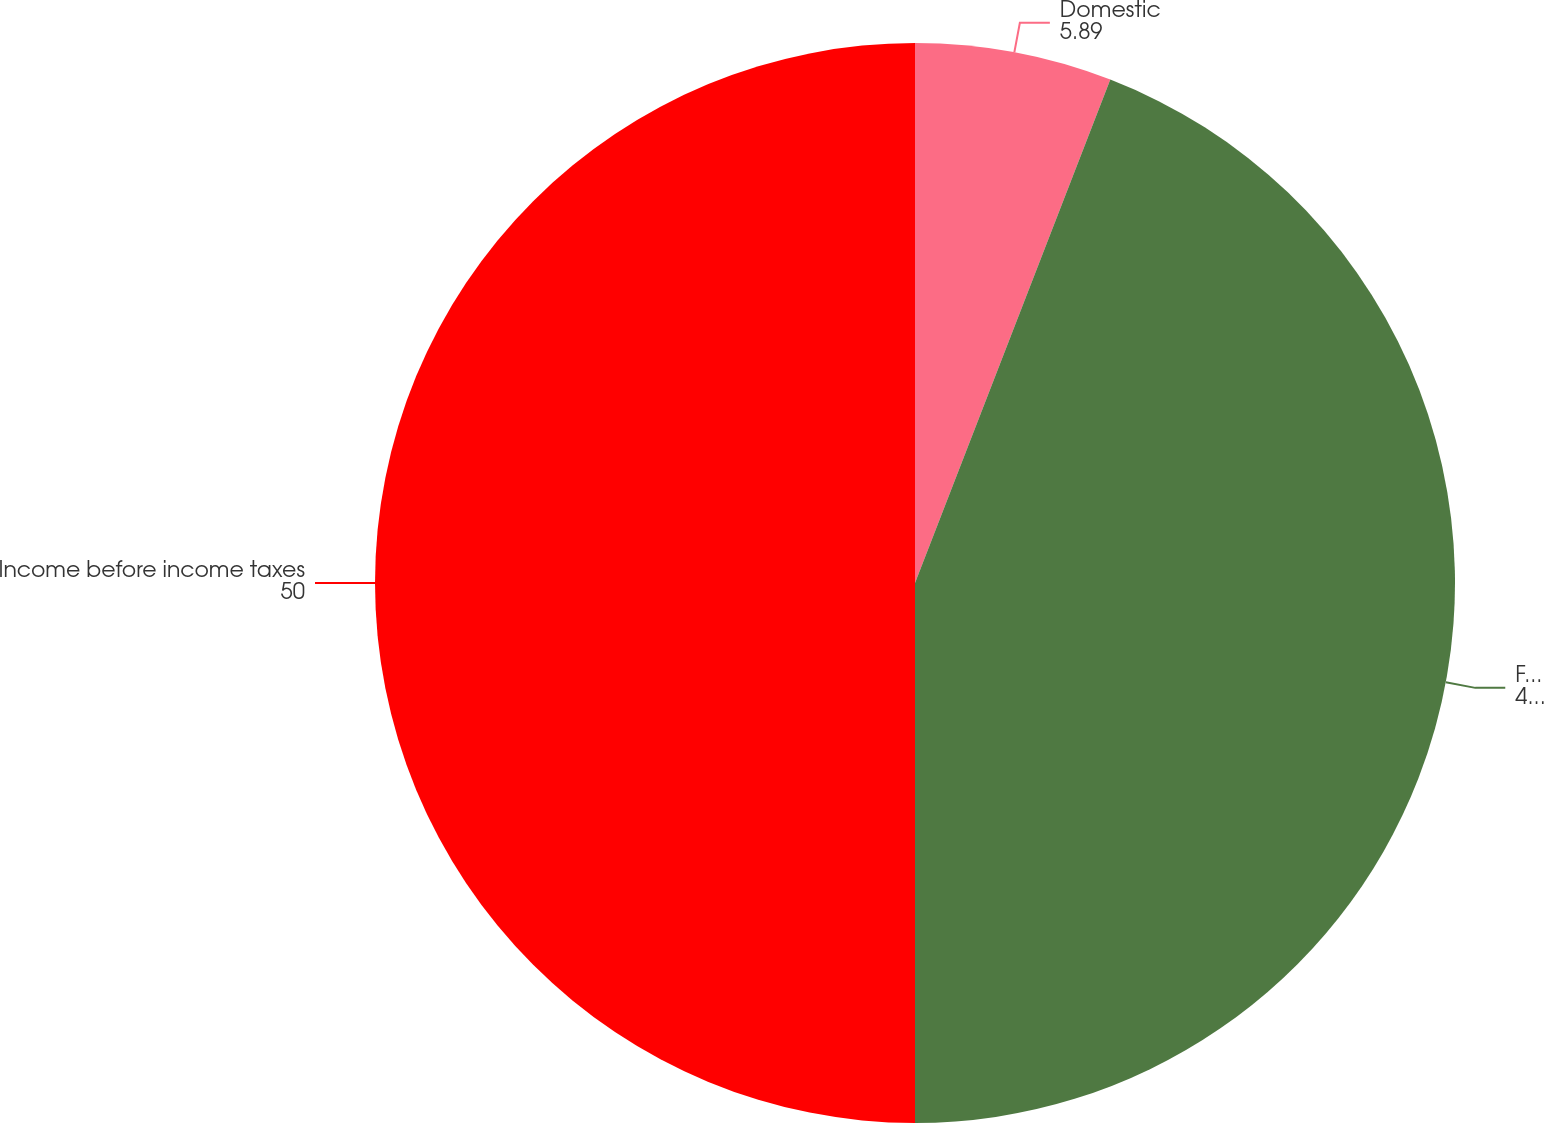<chart> <loc_0><loc_0><loc_500><loc_500><pie_chart><fcel>Domestic<fcel>Foreign<fcel>Income before income taxes<nl><fcel>5.89%<fcel>44.11%<fcel>50.0%<nl></chart> 